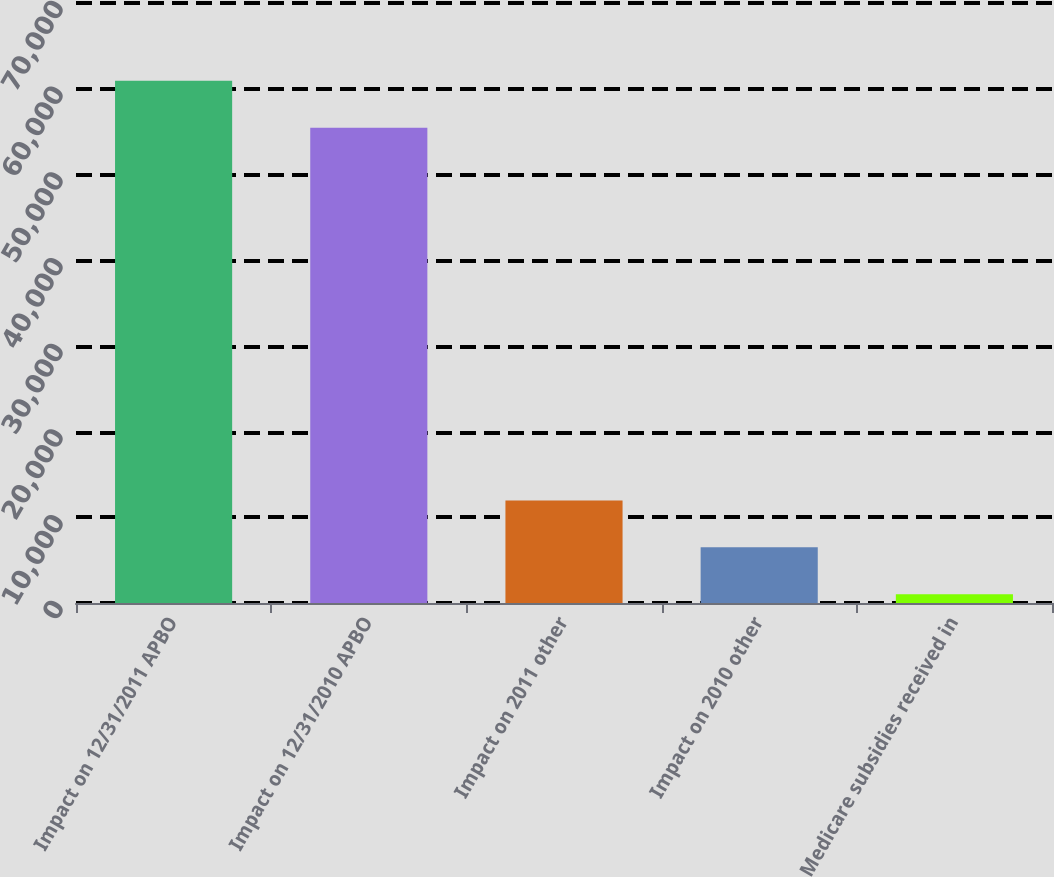Convert chart. <chart><loc_0><loc_0><loc_500><loc_500><bar_chart><fcel>Impact on 12/31/2011 APBO<fcel>Impact on 12/31/2010 APBO<fcel>Impact on 2011 other<fcel>Impact on 2010 other<fcel>Medicare subsidies received in<nl><fcel>60924.9<fcel>55459<fcel>11956.8<fcel>6490.9<fcel>1025<nl></chart> 